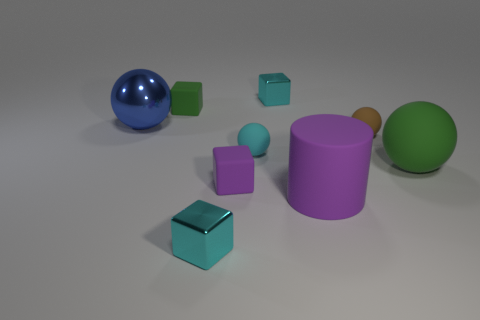Subtract all tiny cyan balls. How many balls are left? 3 Subtract all blue spheres. How many spheres are left? 3 Subtract all cubes. How many objects are left? 5 Subtract 1 cylinders. How many cylinders are left? 0 Subtract all yellow cubes. Subtract all yellow cylinders. How many cubes are left? 4 Subtract all yellow cylinders. How many green blocks are left? 1 Subtract all large gray matte things. Subtract all metallic spheres. How many objects are left? 8 Add 4 tiny matte spheres. How many tiny matte spheres are left? 6 Add 7 big green things. How many big green things exist? 8 Subtract 0 blue cubes. How many objects are left? 9 